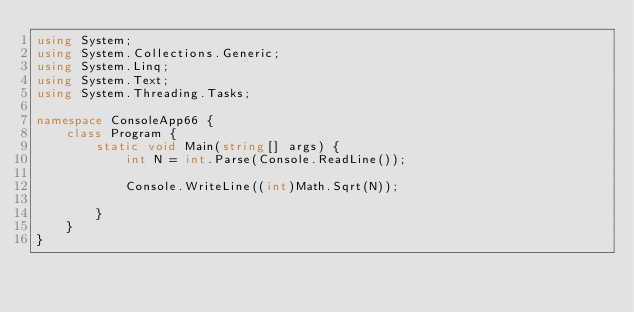Convert code to text. <code><loc_0><loc_0><loc_500><loc_500><_C#_>using System;
using System.Collections.Generic;
using System.Linq;
using System.Text;
using System.Threading.Tasks;

namespace ConsoleApp66 {
    class Program {
        static void Main(string[] args) {
            int N = int.Parse(Console.ReadLine());

            Console.WriteLine((int)Math.Sqrt(N));

        }
    }
}
</code> 